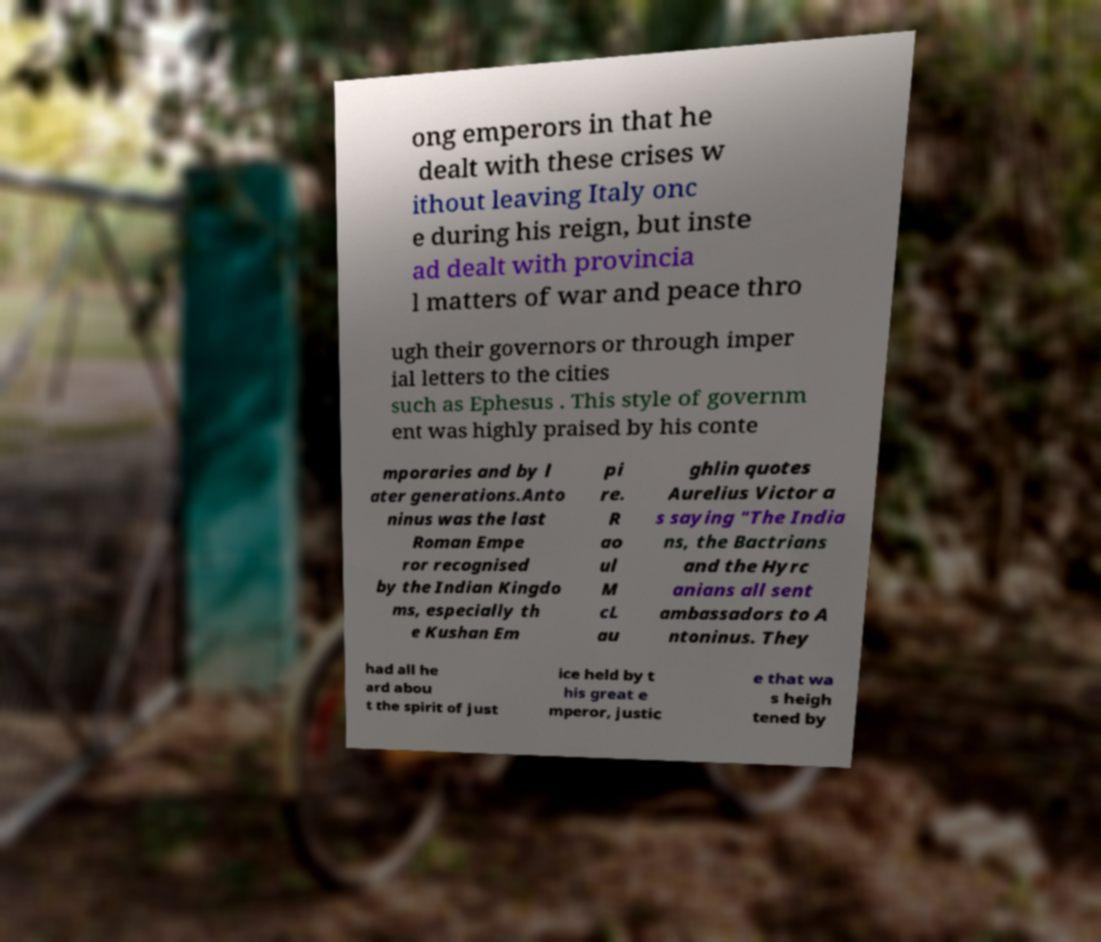I need the written content from this picture converted into text. Can you do that? ong emperors in that he dealt with these crises w ithout leaving Italy onc e during his reign, but inste ad dealt with provincia l matters of war and peace thro ugh their governors or through imper ial letters to the cities such as Ephesus . This style of governm ent was highly praised by his conte mporaries and by l ater generations.Anto ninus was the last Roman Empe ror recognised by the Indian Kingdo ms, especially th e Kushan Em pi re. R ao ul M cL au ghlin quotes Aurelius Victor a s saying "The India ns, the Bactrians and the Hyrc anians all sent ambassadors to A ntoninus. They had all he ard abou t the spirit of just ice held by t his great e mperor, justic e that wa s heigh tened by 